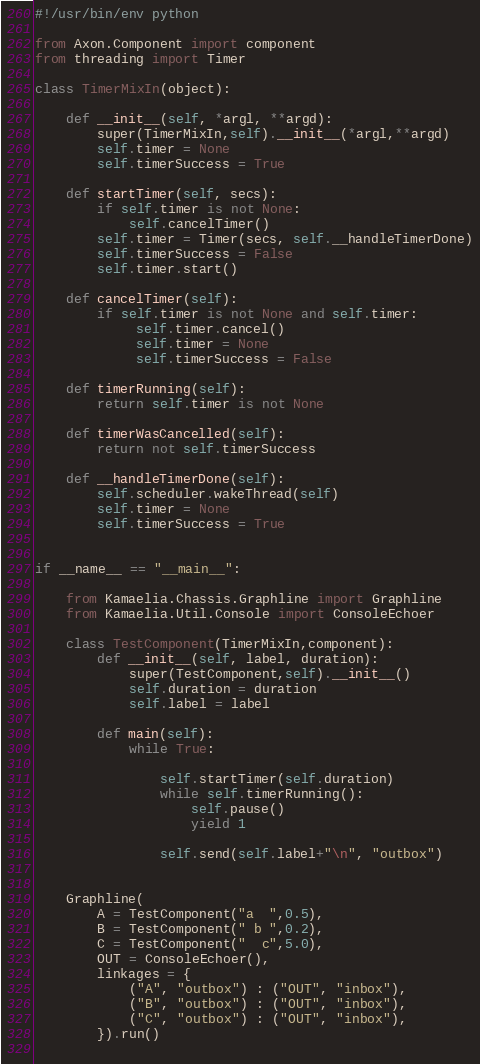<code> <loc_0><loc_0><loc_500><loc_500><_Python_>#!/usr/bin/env python

from Axon.Component import component
from threading import Timer

class TimerMixIn(object):
  
    def __init__(self, *argl, **argd):
        super(TimerMixIn,self).__init__(*argl,**argd)
        self.timer = None
        self.timerSuccess = True
          
    def startTimer(self, secs):
        if self.timer is not None:
            self.cancelTimer()
        self.timer = Timer(secs, self.__handleTimerDone)
        self.timerSuccess = False
        self.timer.start()
  
    def cancelTimer(self):
        if self.timer is not None and self.timer:
             self.timer.cancel()
             self.timer = None
             self.timerSuccess = False
  
    def timerRunning(self):
        return self.timer is not None
        
    def timerWasCancelled(self):
        return not self.timerSuccess
  
    def __handleTimerDone(self):
        self.scheduler.wakeThread(self)
        self.timer = None
        self.timerSuccess = True
        

if __name__ == "__main__":
    
    from Kamaelia.Chassis.Graphline import Graphline
    from Kamaelia.Util.Console import ConsoleEchoer
        
    class TestComponent(TimerMixIn,component):
        def __init__(self, label, duration):
            super(TestComponent,self).__init__()
            self.duration = duration
            self.label = label
            
        def main(self):
            while True:
            
                self.startTimer(self.duration)
                while self.timerRunning():
                    self.pause()
                    yield 1
                    
                self.send(self.label+"\n", "outbox")
                

    Graphline(
        A = TestComponent("a  ",0.5),
        B = TestComponent(" b ",0.2),
        C = TestComponent("  c",5.0),
        OUT = ConsoleEchoer(),
        linkages = {
            ("A", "outbox") : ("OUT", "inbox"),
            ("B", "outbox") : ("OUT", "inbox"),
            ("C", "outbox") : ("OUT", "inbox"),
        }).run()
    </code> 